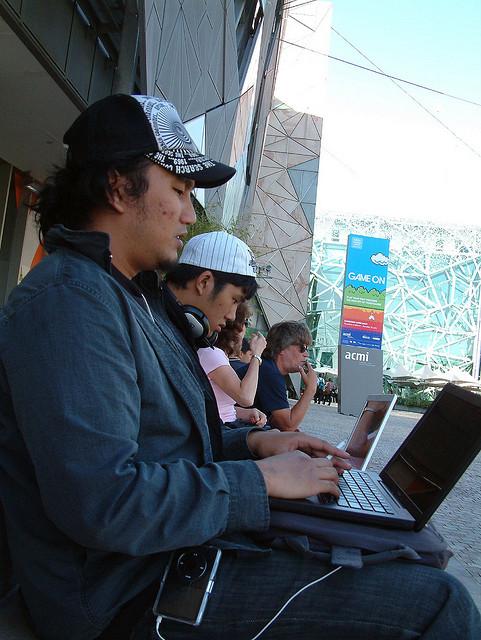What kind of computer is the gentleman using?
Give a very brief answer. Laptop. Is this person stressed out?
Answer briefly. Yes. What color are the tables?
Short answer required. Black. What style hat is the man wearing?
Quick response, please. Baseball. Is the sky overcast?
Quick response, please. No. What kind of hat is the man wearing?
Short answer required. Black. What color is the shirt of the man that is closest to the camera?
Be succinct. Blue. Is it warm or cold outside?
Quick response, please. Warm. What is the man holding?
Concise answer only. Laptop. How many people in the shot?
Quick response, please. 4. Is there an item in the photo that would keep a person dry in the rain?
Concise answer only. No. How many people are shown?
Be succinct. 4. Are the people playing?
Concise answer only. Yes. Is there a ceiling in this picture?
Concise answer only. No. 